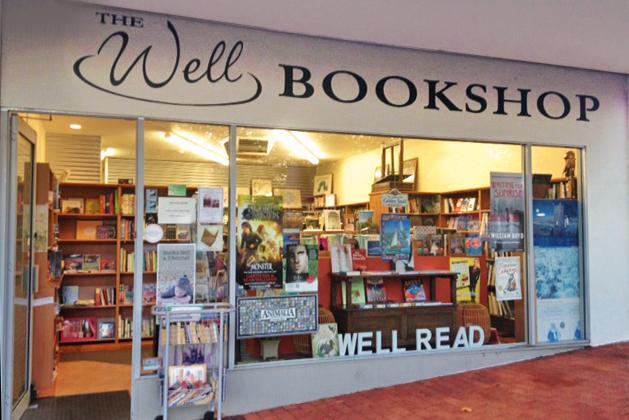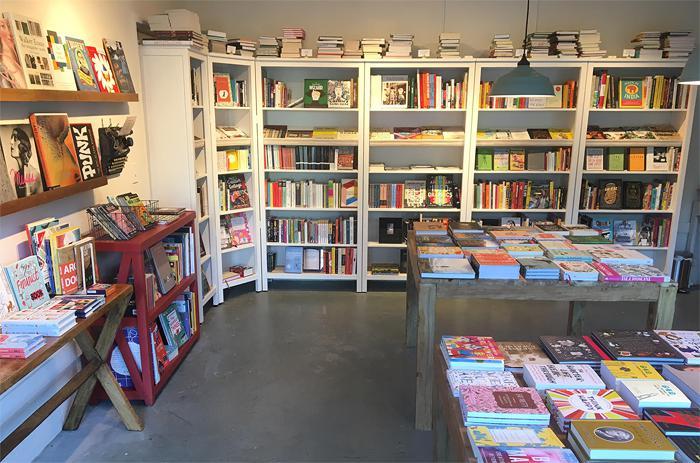The first image is the image on the left, the second image is the image on the right. For the images displayed, is the sentence "There are at least two people in the image on the left." factually correct? Answer yes or no. No. 